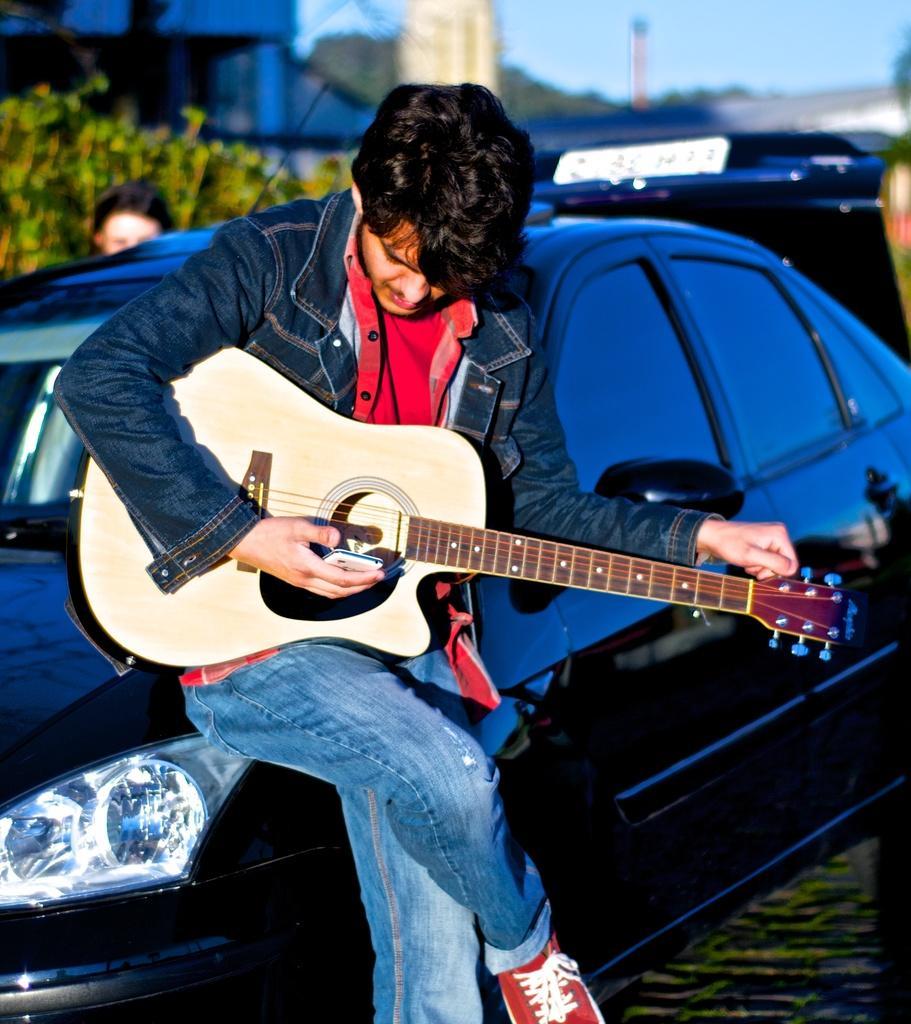Can you describe this image briefly? It is taken outside of the building where one person is sitting on the car and wearing jacket and holding a guitar and one phone in the other hand behind him there are trees and building and another vehicle. 